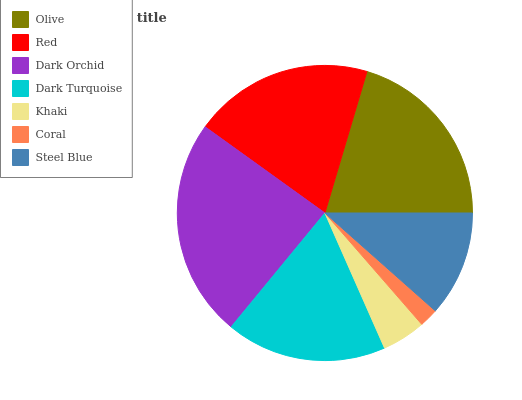Is Coral the minimum?
Answer yes or no. Yes. Is Dark Orchid the maximum?
Answer yes or no. Yes. Is Red the minimum?
Answer yes or no. No. Is Red the maximum?
Answer yes or no. No. Is Olive greater than Red?
Answer yes or no. Yes. Is Red less than Olive?
Answer yes or no. Yes. Is Red greater than Olive?
Answer yes or no. No. Is Olive less than Red?
Answer yes or no. No. Is Dark Turquoise the high median?
Answer yes or no. Yes. Is Dark Turquoise the low median?
Answer yes or no. Yes. Is Steel Blue the high median?
Answer yes or no. No. Is Khaki the low median?
Answer yes or no. No. 